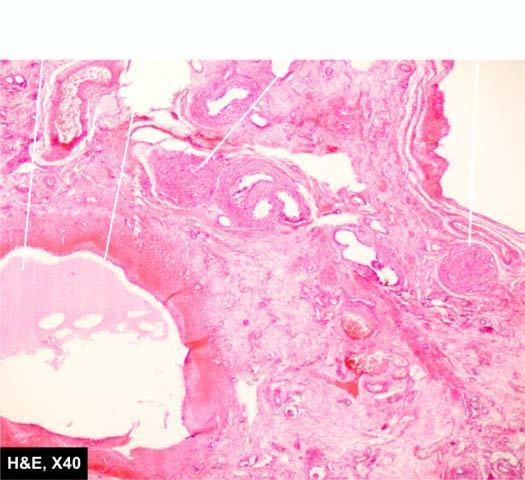what are there lined by flattened epithelium while the intervening parenchyma consists of primitive connective tissue and cartilage?
Answer the question using a single word or phrase. Cysts 